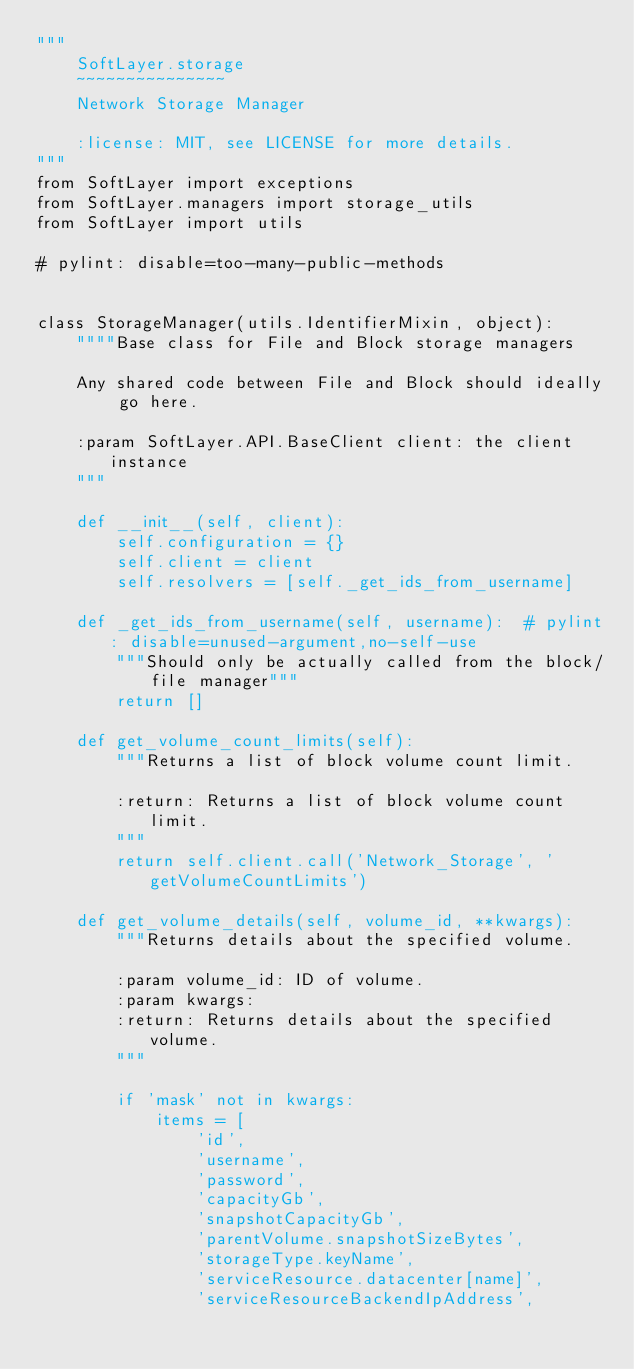Convert code to text. <code><loc_0><loc_0><loc_500><loc_500><_Python_>"""
    SoftLayer.storage
    ~~~~~~~~~~~~~~~
    Network Storage Manager

    :license: MIT, see LICENSE for more details.
"""
from SoftLayer import exceptions
from SoftLayer.managers import storage_utils
from SoftLayer import utils

# pylint: disable=too-many-public-methods


class StorageManager(utils.IdentifierMixin, object):
    """"Base class for File and Block storage managers

    Any shared code between File and Block should ideally go here.

    :param SoftLayer.API.BaseClient client: the client instance
    """

    def __init__(self, client):
        self.configuration = {}
        self.client = client
        self.resolvers = [self._get_ids_from_username]

    def _get_ids_from_username(self, username):  # pylint: disable=unused-argument,no-self-use
        """Should only be actually called from the block/file manager"""
        return []

    def get_volume_count_limits(self):
        """Returns a list of block volume count limit.

        :return: Returns a list of block volume count limit.
        """
        return self.client.call('Network_Storage', 'getVolumeCountLimits')

    def get_volume_details(self, volume_id, **kwargs):
        """Returns details about the specified volume.

        :param volume_id: ID of volume.
        :param kwargs:
        :return: Returns details about the specified volume.
        """

        if 'mask' not in kwargs:
            items = [
                'id',
                'username',
                'password',
                'capacityGb',
                'snapshotCapacityGb',
                'parentVolume.snapshotSizeBytes',
                'storageType.keyName',
                'serviceResource.datacenter[name]',
                'serviceResourceBackendIpAddress',</code> 